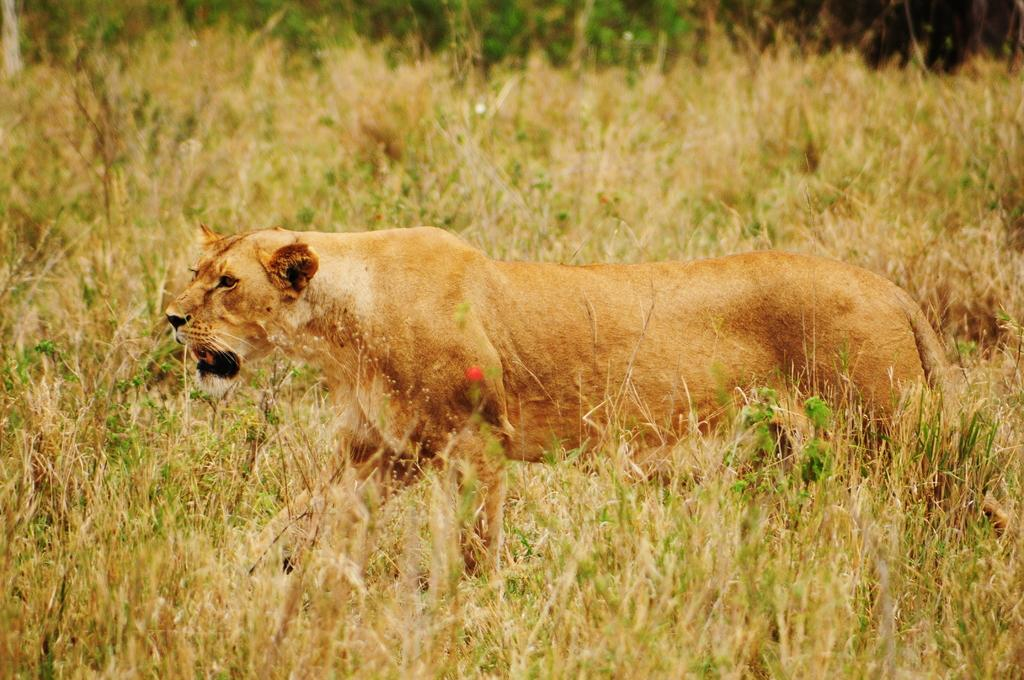What type of creature is present in the image? There is an animal in the image. Where is the animal located? The animal is on the ground. What can be seen in the background of the image? There are plants visible in the background of the image. What is the animal discussing with the plants in the image? There is no discussion taking place in the image, as animals do not have the ability to engage in discussions with plants. 